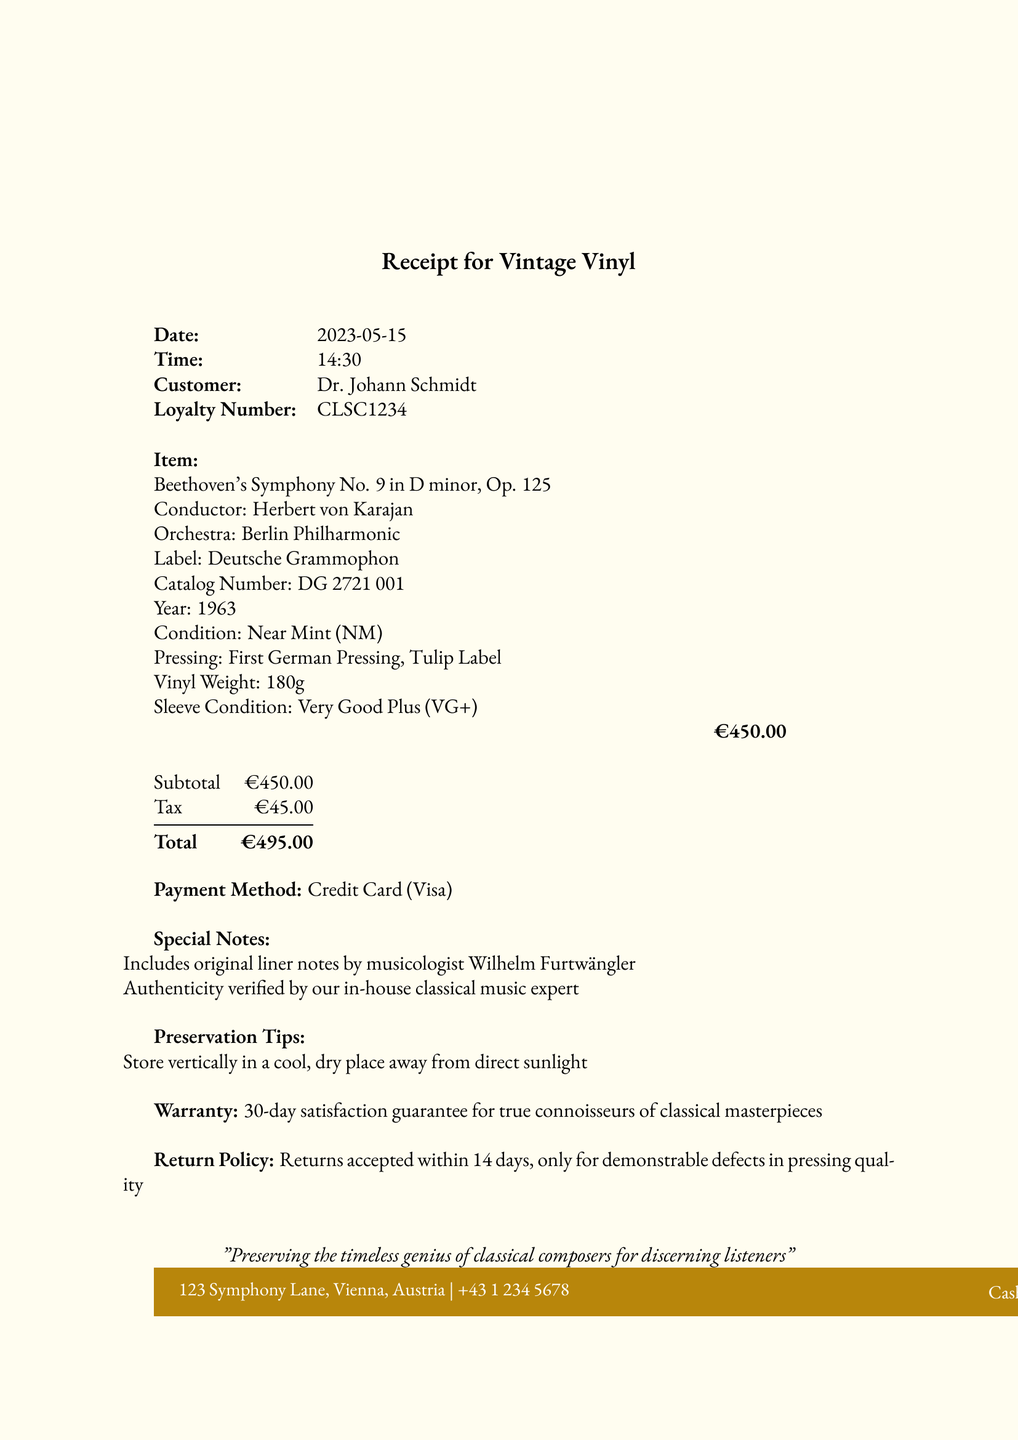What is the store name? The store name is listed at the top of the receipt.
Answer: Classical Vinyl Treasures What is the date of purchase? The date is specified on the receipt.
Answer: 2023-05-15 Who conducted Beethoven's Symphony No. 9? The conductor is mentioned under the item details.
Answer: Herbert von Karajan What is the price of the vinyl record? The price is indicated in the itemized section of the receipt.
Answer: €450 What is the condition of the vinyl? The condition is specified alongside the item details.
Answer: Near Mint (NM) What is the sleeve condition? The sleeve condition is noted on the receipt as well.
Answer: Very Good Plus (VG+) What is the total amount paid? The total is calculated and shown in a summary section.
Answer: €495 What warranty is offered with the purchase? The warranty information is provided towards the end of the document.
Answer: 30-day satisfaction guarantee How long do customers have to return the item? The return policy section mentions the time frame for returns.
Answer: 14 days What type of payment was used? The payment method is clearly listed near the end of the receipt.
Answer: Credit Card (Visa) 